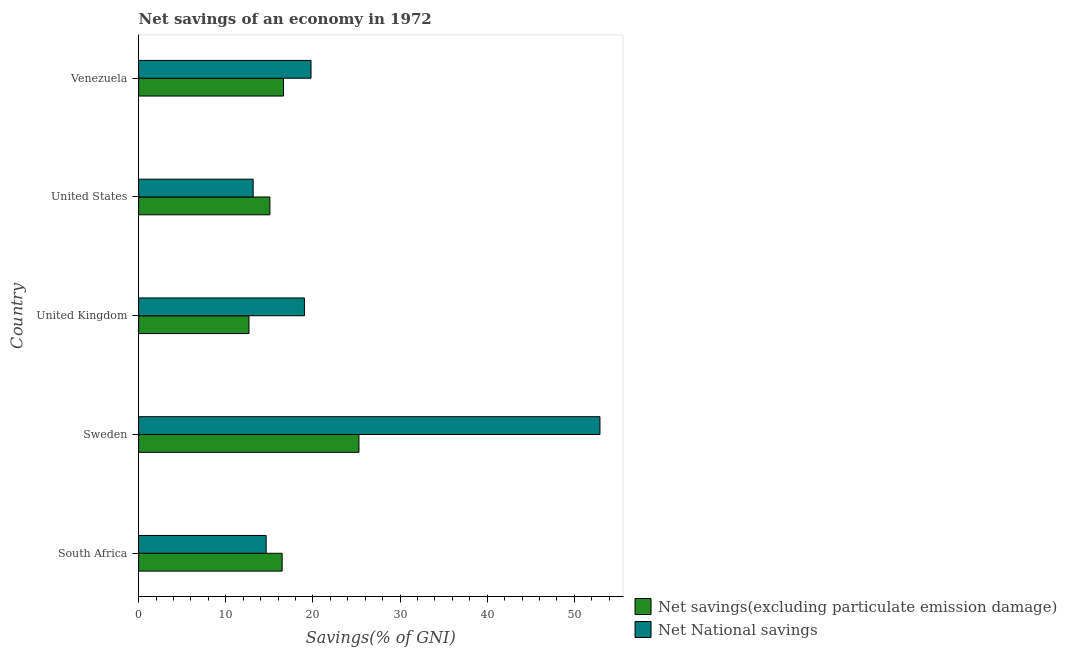How many different coloured bars are there?
Give a very brief answer. 2. How many groups of bars are there?
Offer a terse response. 5. Are the number of bars per tick equal to the number of legend labels?
Make the answer very short. Yes. How many bars are there on the 2nd tick from the top?
Provide a succinct answer. 2. What is the label of the 3rd group of bars from the top?
Your response must be concise. United Kingdom. In how many cases, is the number of bars for a given country not equal to the number of legend labels?
Provide a succinct answer. 0. What is the net national savings in South Africa?
Ensure brevity in your answer.  14.64. Across all countries, what is the maximum net savings(excluding particulate emission damage)?
Provide a succinct answer. 25.28. Across all countries, what is the minimum net savings(excluding particulate emission damage)?
Your response must be concise. 12.66. In which country was the net national savings minimum?
Offer a very short reply. United States. What is the total net savings(excluding particulate emission damage) in the graph?
Your response must be concise. 86.11. What is the difference between the net savings(excluding particulate emission damage) in Sweden and that in United Kingdom?
Your response must be concise. 12.62. What is the difference between the net savings(excluding particulate emission damage) in United Kingdom and the net national savings in South Africa?
Your response must be concise. -1.97. What is the average net savings(excluding particulate emission damage) per country?
Make the answer very short. 17.22. What is the difference between the net savings(excluding particulate emission damage) and net national savings in United States?
Your response must be concise. 1.92. What is the ratio of the net savings(excluding particulate emission damage) in South Africa to that in United Kingdom?
Offer a very short reply. 1.3. Is the net national savings in Sweden less than that in United States?
Provide a succinct answer. No. Is the difference between the net national savings in Sweden and Venezuela greater than the difference between the net savings(excluding particulate emission damage) in Sweden and Venezuela?
Keep it short and to the point. Yes. What is the difference between the highest and the second highest net savings(excluding particulate emission damage)?
Your response must be concise. 8.66. What is the difference between the highest and the lowest net national savings?
Ensure brevity in your answer.  39.8. What does the 1st bar from the top in United States represents?
Provide a short and direct response. Net National savings. What does the 1st bar from the bottom in Sweden represents?
Provide a succinct answer. Net savings(excluding particulate emission damage). Are all the bars in the graph horizontal?
Your answer should be compact. Yes. How many legend labels are there?
Make the answer very short. 2. How are the legend labels stacked?
Offer a terse response. Vertical. What is the title of the graph?
Provide a succinct answer. Net savings of an economy in 1972. Does "Nonresident" appear as one of the legend labels in the graph?
Make the answer very short. No. What is the label or title of the X-axis?
Ensure brevity in your answer.  Savings(% of GNI). What is the Savings(% of GNI) of Net savings(excluding particulate emission damage) in South Africa?
Ensure brevity in your answer.  16.47. What is the Savings(% of GNI) of Net National savings in South Africa?
Give a very brief answer. 14.64. What is the Savings(% of GNI) of Net savings(excluding particulate emission damage) in Sweden?
Your response must be concise. 25.28. What is the Savings(% of GNI) of Net National savings in Sweden?
Make the answer very short. 52.94. What is the Savings(% of GNI) in Net savings(excluding particulate emission damage) in United Kingdom?
Keep it short and to the point. 12.66. What is the Savings(% of GNI) of Net National savings in United Kingdom?
Make the answer very short. 19.03. What is the Savings(% of GNI) in Net savings(excluding particulate emission damage) in United States?
Ensure brevity in your answer.  15.06. What is the Savings(% of GNI) in Net National savings in United States?
Offer a terse response. 13.14. What is the Savings(% of GNI) in Net savings(excluding particulate emission damage) in Venezuela?
Your response must be concise. 16.63. What is the Savings(% of GNI) of Net National savings in Venezuela?
Your answer should be very brief. 19.78. Across all countries, what is the maximum Savings(% of GNI) of Net savings(excluding particulate emission damage)?
Make the answer very short. 25.28. Across all countries, what is the maximum Savings(% of GNI) of Net National savings?
Your response must be concise. 52.94. Across all countries, what is the minimum Savings(% of GNI) of Net savings(excluding particulate emission damage)?
Your answer should be compact. 12.66. Across all countries, what is the minimum Savings(% of GNI) in Net National savings?
Provide a short and direct response. 13.14. What is the total Savings(% of GNI) of Net savings(excluding particulate emission damage) in the graph?
Ensure brevity in your answer.  86.11. What is the total Savings(% of GNI) of Net National savings in the graph?
Provide a succinct answer. 119.53. What is the difference between the Savings(% of GNI) in Net savings(excluding particulate emission damage) in South Africa and that in Sweden?
Offer a very short reply. -8.81. What is the difference between the Savings(% of GNI) in Net National savings in South Africa and that in Sweden?
Ensure brevity in your answer.  -38.31. What is the difference between the Savings(% of GNI) in Net savings(excluding particulate emission damage) in South Africa and that in United Kingdom?
Give a very brief answer. 3.81. What is the difference between the Savings(% of GNI) of Net National savings in South Africa and that in United Kingdom?
Offer a terse response. -4.39. What is the difference between the Savings(% of GNI) in Net savings(excluding particulate emission damage) in South Africa and that in United States?
Make the answer very short. 1.41. What is the difference between the Savings(% of GNI) of Net National savings in South Africa and that in United States?
Your answer should be compact. 1.49. What is the difference between the Savings(% of GNI) of Net savings(excluding particulate emission damage) in South Africa and that in Venezuela?
Your response must be concise. -0.16. What is the difference between the Savings(% of GNI) in Net National savings in South Africa and that in Venezuela?
Your answer should be very brief. -5.15. What is the difference between the Savings(% of GNI) of Net savings(excluding particulate emission damage) in Sweden and that in United Kingdom?
Provide a short and direct response. 12.62. What is the difference between the Savings(% of GNI) of Net National savings in Sweden and that in United Kingdom?
Offer a terse response. 33.92. What is the difference between the Savings(% of GNI) in Net savings(excluding particulate emission damage) in Sweden and that in United States?
Your response must be concise. 10.22. What is the difference between the Savings(% of GNI) of Net National savings in Sweden and that in United States?
Offer a very short reply. 39.8. What is the difference between the Savings(% of GNI) in Net savings(excluding particulate emission damage) in Sweden and that in Venezuela?
Offer a very short reply. 8.66. What is the difference between the Savings(% of GNI) in Net National savings in Sweden and that in Venezuela?
Your answer should be very brief. 33.16. What is the difference between the Savings(% of GNI) in Net savings(excluding particulate emission damage) in United Kingdom and that in United States?
Provide a succinct answer. -2.4. What is the difference between the Savings(% of GNI) of Net National savings in United Kingdom and that in United States?
Provide a short and direct response. 5.88. What is the difference between the Savings(% of GNI) in Net savings(excluding particulate emission damage) in United Kingdom and that in Venezuela?
Keep it short and to the point. -3.96. What is the difference between the Savings(% of GNI) in Net National savings in United Kingdom and that in Venezuela?
Offer a very short reply. -0.76. What is the difference between the Savings(% of GNI) in Net savings(excluding particulate emission damage) in United States and that in Venezuela?
Make the answer very short. -1.56. What is the difference between the Savings(% of GNI) in Net National savings in United States and that in Venezuela?
Offer a terse response. -6.64. What is the difference between the Savings(% of GNI) in Net savings(excluding particulate emission damage) in South Africa and the Savings(% of GNI) in Net National savings in Sweden?
Your response must be concise. -36.47. What is the difference between the Savings(% of GNI) of Net savings(excluding particulate emission damage) in South Africa and the Savings(% of GNI) of Net National savings in United Kingdom?
Provide a succinct answer. -2.56. What is the difference between the Savings(% of GNI) of Net savings(excluding particulate emission damage) in South Africa and the Savings(% of GNI) of Net National savings in United States?
Provide a succinct answer. 3.33. What is the difference between the Savings(% of GNI) of Net savings(excluding particulate emission damage) in South Africa and the Savings(% of GNI) of Net National savings in Venezuela?
Your response must be concise. -3.31. What is the difference between the Savings(% of GNI) in Net savings(excluding particulate emission damage) in Sweden and the Savings(% of GNI) in Net National savings in United Kingdom?
Keep it short and to the point. 6.26. What is the difference between the Savings(% of GNI) in Net savings(excluding particulate emission damage) in Sweden and the Savings(% of GNI) in Net National savings in United States?
Keep it short and to the point. 12.14. What is the difference between the Savings(% of GNI) of Net savings(excluding particulate emission damage) in Sweden and the Savings(% of GNI) of Net National savings in Venezuela?
Provide a succinct answer. 5.5. What is the difference between the Savings(% of GNI) of Net savings(excluding particulate emission damage) in United Kingdom and the Savings(% of GNI) of Net National savings in United States?
Your response must be concise. -0.48. What is the difference between the Savings(% of GNI) of Net savings(excluding particulate emission damage) in United Kingdom and the Savings(% of GNI) of Net National savings in Venezuela?
Ensure brevity in your answer.  -7.12. What is the difference between the Savings(% of GNI) in Net savings(excluding particulate emission damage) in United States and the Savings(% of GNI) in Net National savings in Venezuela?
Offer a very short reply. -4.72. What is the average Savings(% of GNI) in Net savings(excluding particulate emission damage) per country?
Keep it short and to the point. 17.22. What is the average Savings(% of GNI) in Net National savings per country?
Offer a terse response. 23.91. What is the difference between the Savings(% of GNI) of Net savings(excluding particulate emission damage) and Savings(% of GNI) of Net National savings in South Africa?
Make the answer very short. 1.83. What is the difference between the Savings(% of GNI) in Net savings(excluding particulate emission damage) and Savings(% of GNI) in Net National savings in Sweden?
Keep it short and to the point. -27.66. What is the difference between the Savings(% of GNI) of Net savings(excluding particulate emission damage) and Savings(% of GNI) of Net National savings in United Kingdom?
Provide a succinct answer. -6.36. What is the difference between the Savings(% of GNI) of Net savings(excluding particulate emission damage) and Savings(% of GNI) of Net National savings in United States?
Make the answer very short. 1.92. What is the difference between the Savings(% of GNI) in Net savings(excluding particulate emission damage) and Savings(% of GNI) in Net National savings in Venezuela?
Offer a very short reply. -3.16. What is the ratio of the Savings(% of GNI) of Net savings(excluding particulate emission damage) in South Africa to that in Sweden?
Offer a very short reply. 0.65. What is the ratio of the Savings(% of GNI) of Net National savings in South Africa to that in Sweden?
Your answer should be very brief. 0.28. What is the ratio of the Savings(% of GNI) in Net savings(excluding particulate emission damage) in South Africa to that in United Kingdom?
Your answer should be compact. 1.3. What is the ratio of the Savings(% of GNI) in Net National savings in South Africa to that in United Kingdom?
Ensure brevity in your answer.  0.77. What is the ratio of the Savings(% of GNI) of Net savings(excluding particulate emission damage) in South Africa to that in United States?
Make the answer very short. 1.09. What is the ratio of the Savings(% of GNI) in Net National savings in South Africa to that in United States?
Provide a short and direct response. 1.11. What is the ratio of the Savings(% of GNI) in Net savings(excluding particulate emission damage) in South Africa to that in Venezuela?
Make the answer very short. 0.99. What is the ratio of the Savings(% of GNI) of Net National savings in South Africa to that in Venezuela?
Your answer should be compact. 0.74. What is the ratio of the Savings(% of GNI) of Net savings(excluding particulate emission damage) in Sweden to that in United Kingdom?
Provide a succinct answer. 2. What is the ratio of the Savings(% of GNI) of Net National savings in Sweden to that in United Kingdom?
Make the answer very short. 2.78. What is the ratio of the Savings(% of GNI) in Net savings(excluding particulate emission damage) in Sweden to that in United States?
Ensure brevity in your answer.  1.68. What is the ratio of the Savings(% of GNI) of Net National savings in Sweden to that in United States?
Offer a terse response. 4.03. What is the ratio of the Savings(% of GNI) of Net savings(excluding particulate emission damage) in Sweden to that in Venezuela?
Provide a succinct answer. 1.52. What is the ratio of the Savings(% of GNI) in Net National savings in Sweden to that in Venezuela?
Your answer should be compact. 2.68. What is the ratio of the Savings(% of GNI) in Net savings(excluding particulate emission damage) in United Kingdom to that in United States?
Offer a very short reply. 0.84. What is the ratio of the Savings(% of GNI) of Net National savings in United Kingdom to that in United States?
Keep it short and to the point. 1.45. What is the ratio of the Savings(% of GNI) in Net savings(excluding particulate emission damage) in United Kingdom to that in Venezuela?
Ensure brevity in your answer.  0.76. What is the ratio of the Savings(% of GNI) in Net National savings in United Kingdom to that in Venezuela?
Your response must be concise. 0.96. What is the ratio of the Savings(% of GNI) of Net savings(excluding particulate emission damage) in United States to that in Venezuela?
Your answer should be very brief. 0.91. What is the ratio of the Savings(% of GNI) of Net National savings in United States to that in Venezuela?
Provide a succinct answer. 0.66. What is the difference between the highest and the second highest Savings(% of GNI) of Net savings(excluding particulate emission damage)?
Provide a succinct answer. 8.66. What is the difference between the highest and the second highest Savings(% of GNI) of Net National savings?
Your response must be concise. 33.16. What is the difference between the highest and the lowest Savings(% of GNI) of Net savings(excluding particulate emission damage)?
Your answer should be very brief. 12.62. What is the difference between the highest and the lowest Savings(% of GNI) in Net National savings?
Provide a short and direct response. 39.8. 